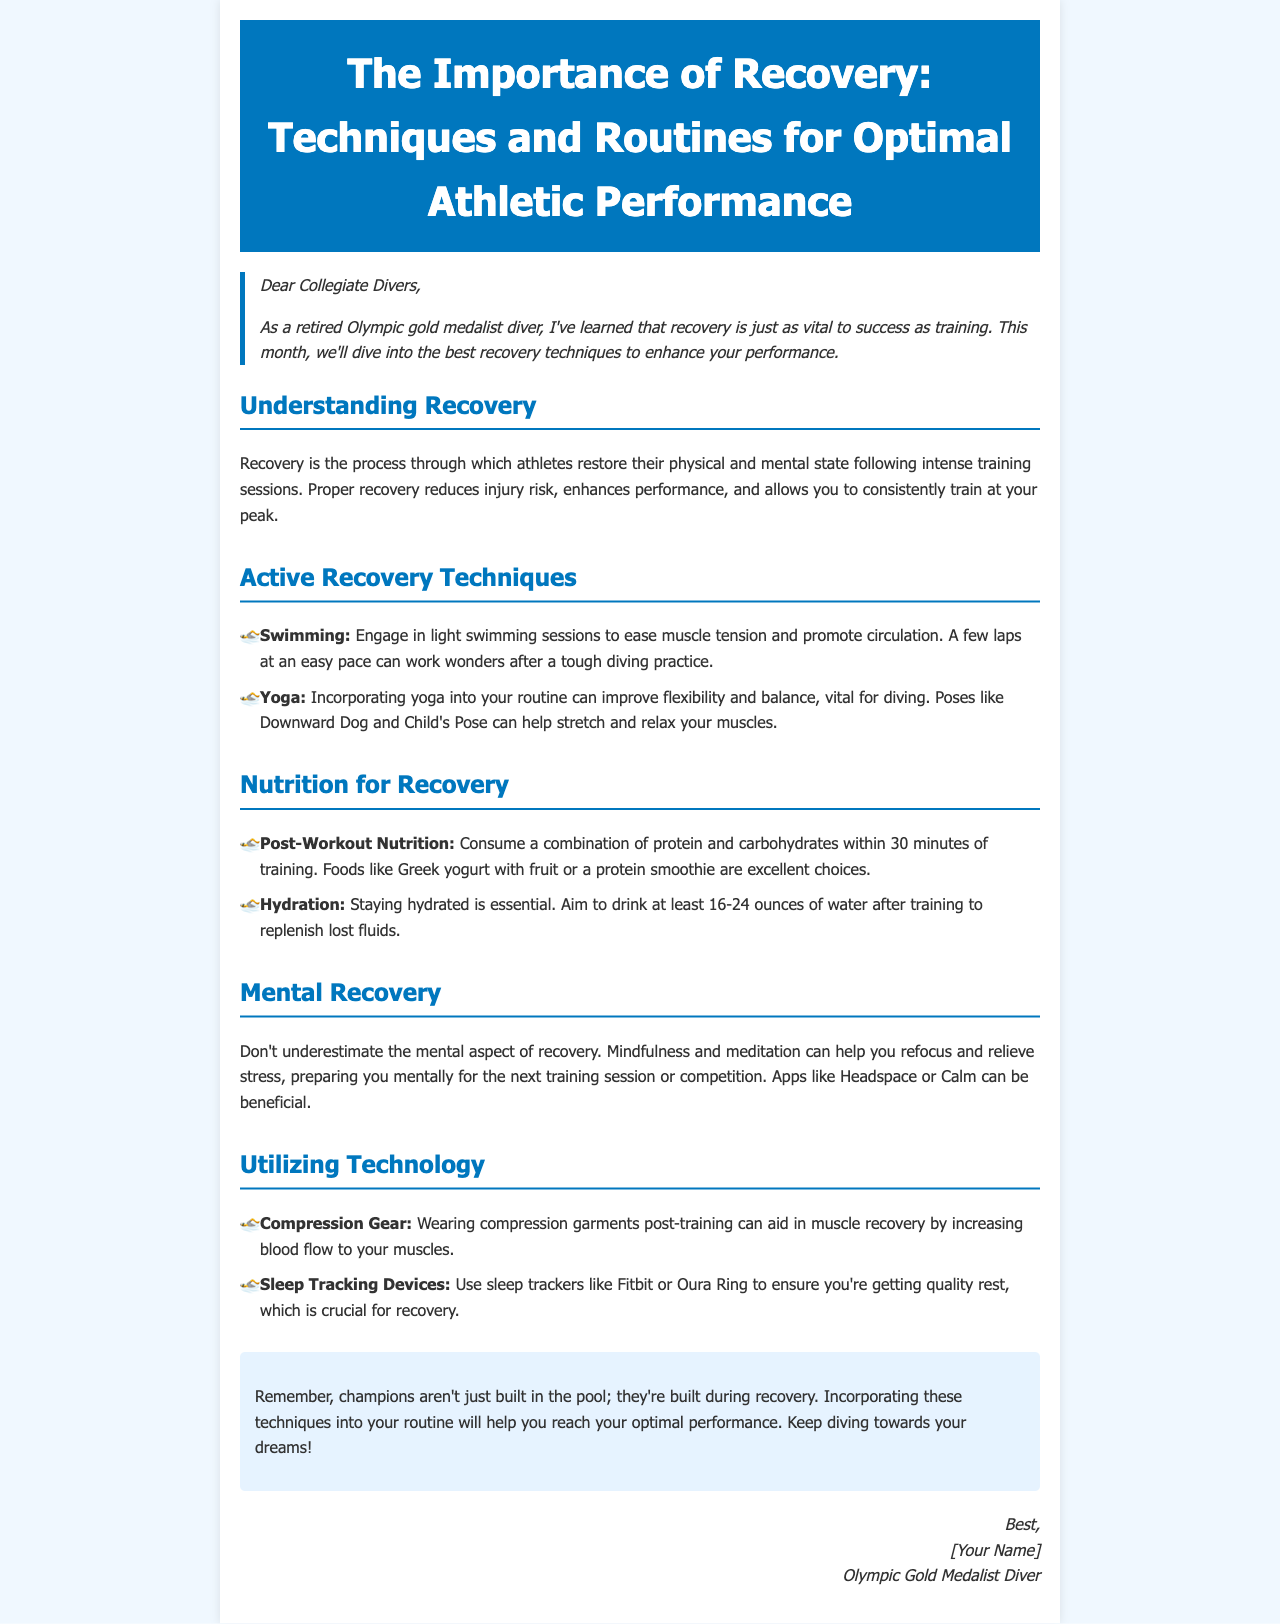What is the main topic of the newsletter? The title of the newsletter indicates that it is focused on recovery techniques and routines for optimal athletic performance.
Answer: The Importance of Recovery: Techniques and Routines for Optimal Athletic Performance Who is the author of the newsletter? The signature section reveals that the author is a retired Olympic gold medalist diver.
Answer: [Your Name] What is one example of an active recovery technique mentioned? The section on active recovery techniques lists swimming and yoga as examples.
Answer: Swimming What should be consumed within 30 minutes post-workout? The nutrition section recommends consuming a combination of protein and carbohydrates soon after training.
Answer: Protein and carbohydrates How much water should be consumed after training? The hydration guideline states that athletes should aim to drink 16-24 ounces of water post-training.
Answer: 16-24 ounces What technology is suggested for aiding muscle recovery? The document mentions compression gear as a technological aid for muscle recovery.
Answer: Compression Gear What is one mental recovery technique suggested in the newsletter? The mental recovery section highlights mindfulness and meditation as essential techniques for recovery.
Answer: Mindfulness What is the purpose of the newsletter? The introductory section indicates that the newsletter aims to share recovery knowledge and techniques for improved performance.
Answer: To enhance performance 